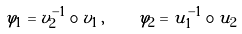<formula> <loc_0><loc_0><loc_500><loc_500>\varphi _ { 1 } = v _ { 2 } ^ { - 1 } \circ v _ { 1 } \, , \quad \varphi _ { 2 } = u _ { 1 } ^ { - 1 } \circ u _ { 2 }</formula> 